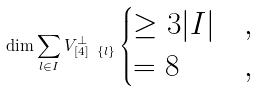<formula> <loc_0><loc_0><loc_500><loc_500>\dim \sum _ { l \in I } V _ { [ 4 ] \ \{ l \} } ^ { \perp } \begin{cases} \geq 3 | I | & , \\ = 8 & , \end{cases}</formula> 